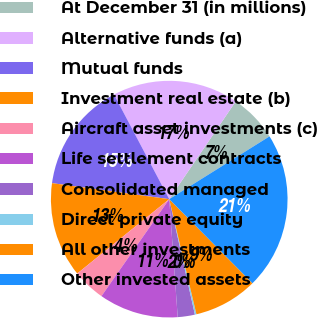Convert chart to OTSL. <chart><loc_0><loc_0><loc_500><loc_500><pie_chart><fcel>At December 31 (in millions)<fcel>Alternative funds (a)<fcel>Mutual funds<fcel>Investment real estate (b)<fcel>Aircraft asset investments (c)<fcel>Life settlement contracts<fcel>Consolidated managed<fcel>Direct private equity<fcel>All other investments<fcel>Other invested assets<nl><fcel>6.59%<fcel>17.24%<fcel>15.11%<fcel>12.98%<fcel>4.47%<fcel>10.85%<fcel>2.34%<fcel>0.21%<fcel>8.72%<fcel>21.49%<nl></chart> 